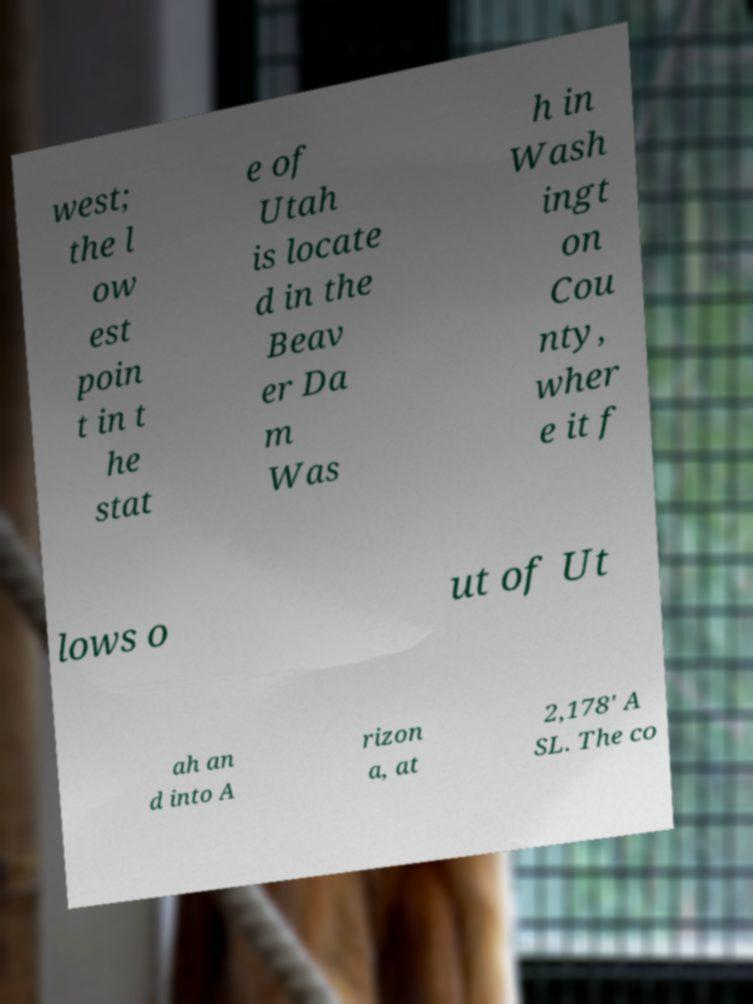There's text embedded in this image that I need extracted. Can you transcribe it verbatim? west; the l ow est poin t in t he stat e of Utah is locate d in the Beav er Da m Was h in Wash ingt on Cou nty, wher e it f lows o ut of Ut ah an d into A rizon a, at 2,178' A SL. The co 